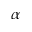<formula> <loc_0><loc_0><loc_500><loc_500>\alpha</formula> 